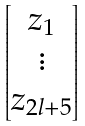<formula> <loc_0><loc_0><loc_500><loc_500>\begin{bmatrix} z _ { 1 } \\ \vdots \\ z _ { 2 l + 5 } \end{bmatrix}</formula> 